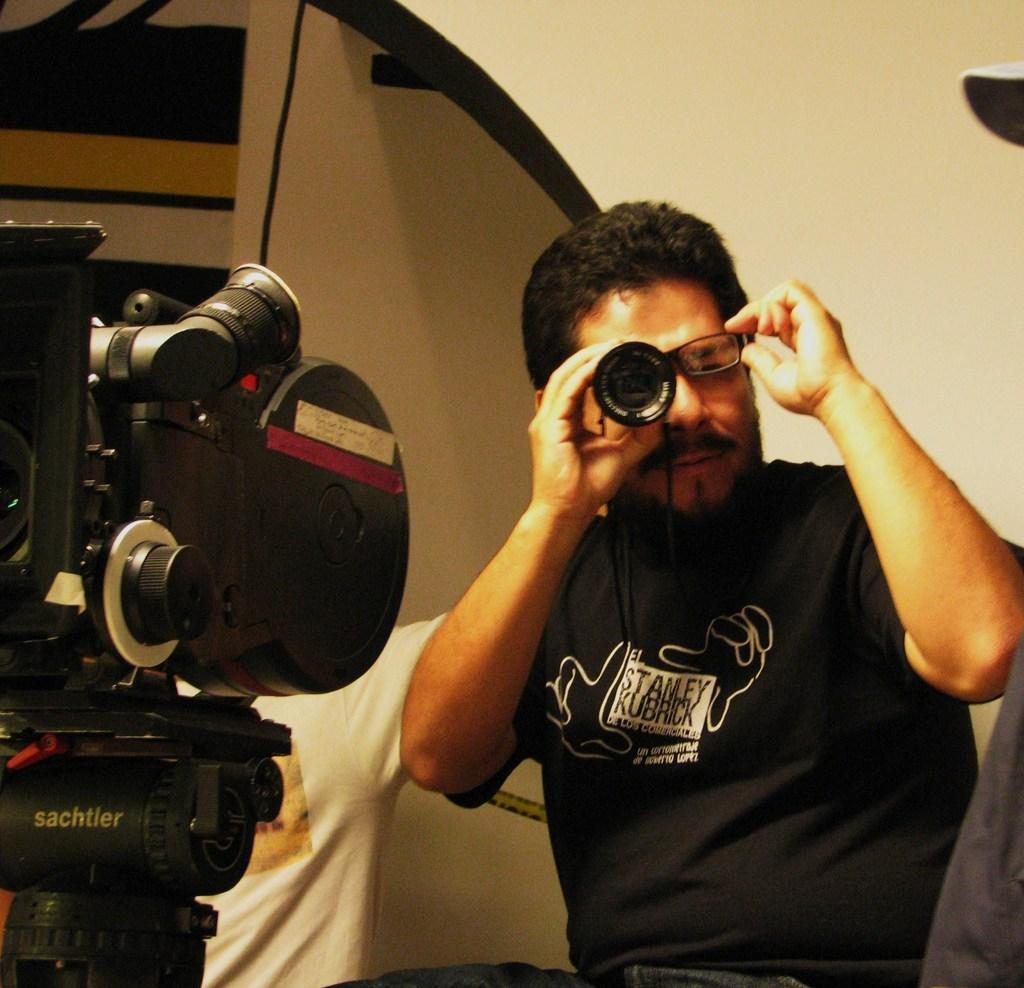Can you describe this image briefly? In this picture we can see two people, a man is seeing with the help of camera lens, in front of them we we can find a camera. 